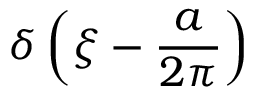<formula> <loc_0><loc_0><loc_500><loc_500>\delta \left ( \xi - { \frac { a } { 2 \pi } } \right )</formula> 